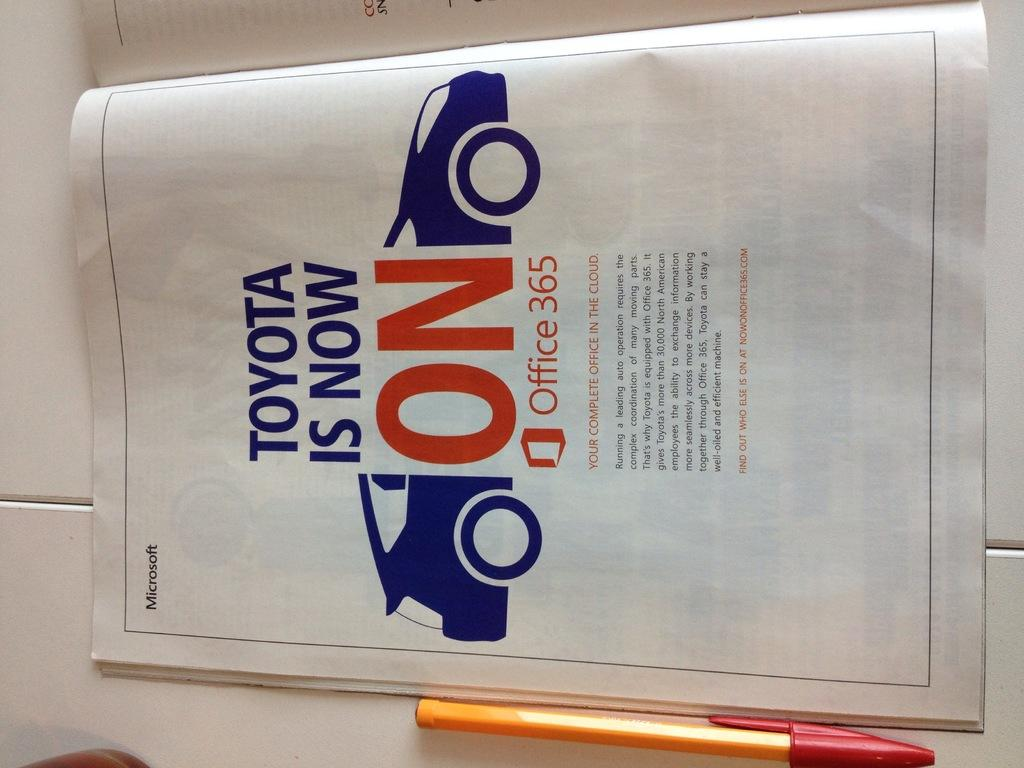<image>
Summarize the visual content of the image. Toyota and Microsoft have teamed up together on this brochure. 